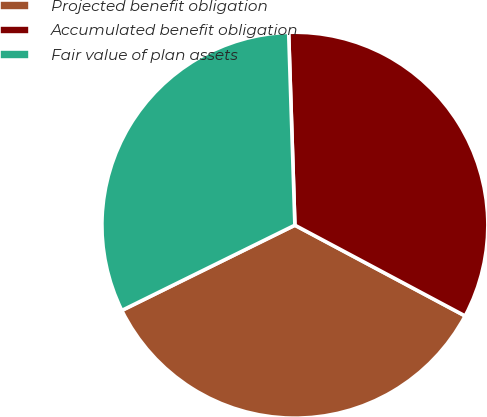Convert chart to OTSL. <chart><loc_0><loc_0><loc_500><loc_500><pie_chart><fcel>Projected benefit obligation<fcel>Accumulated benefit obligation<fcel>Fair value of plan assets<nl><fcel>34.92%<fcel>33.31%<fcel>31.77%<nl></chart> 